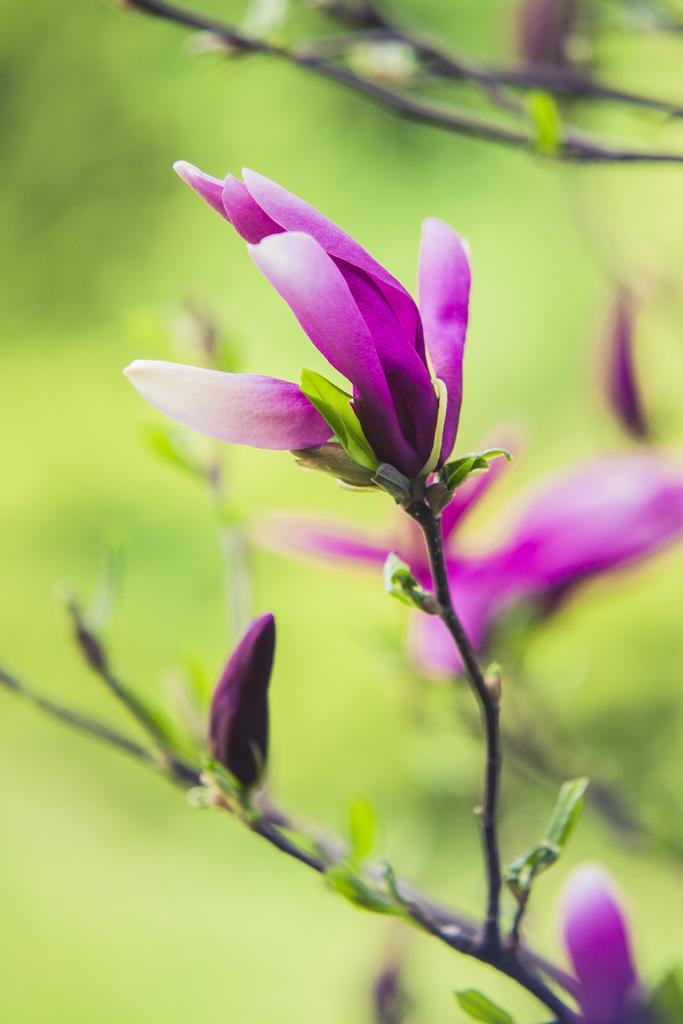What type of plant elements can be seen in the image? There are flowers, leaves, and stems in the image. Can you describe the appearance of the flowers? Unfortunately, the provided facts do not include a description of the flowers. What is the background of the image like? The background of the image is blurry. What type of volleyball is being played in the background of the image? There is no volleyball present in the image; it features flowers, leaves, and stems with a blurry background. What kind of shock is depicted in the image? There is no shock depicted in the image; it features flowers, leaves, and stems with a blurry background. 